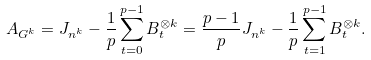<formula> <loc_0><loc_0><loc_500><loc_500>A _ { G ^ { k } } = J _ { n ^ { k } } - \frac { 1 } { p } \sum _ { t = 0 } ^ { p - 1 } B _ { t } ^ { \otimes k } = \frac { p - 1 } { p } J _ { n ^ { k } } - \frac { 1 } { p } \sum _ { t = 1 } ^ { p - 1 } B _ { t } ^ { \otimes k } .</formula> 